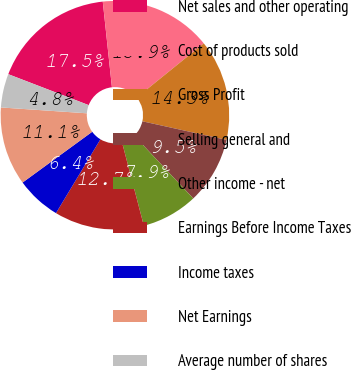<chart> <loc_0><loc_0><loc_500><loc_500><pie_chart><fcel>Net sales and other operating<fcel>Cost of products sold<fcel>Gross Profit<fcel>Selling general and<fcel>Other income - net<fcel>Earnings Before Income Taxes<fcel>Income taxes<fcel>Net Earnings<fcel>Average number of shares<nl><fcel>17.46%<fcel>15.87%<fcel>14.29%<fcel>9.52%<fcel>7.94%<fcel>12.7%<fcel>6.35%<fcel>11.11%<fcel>4.76%<nl></chart> 